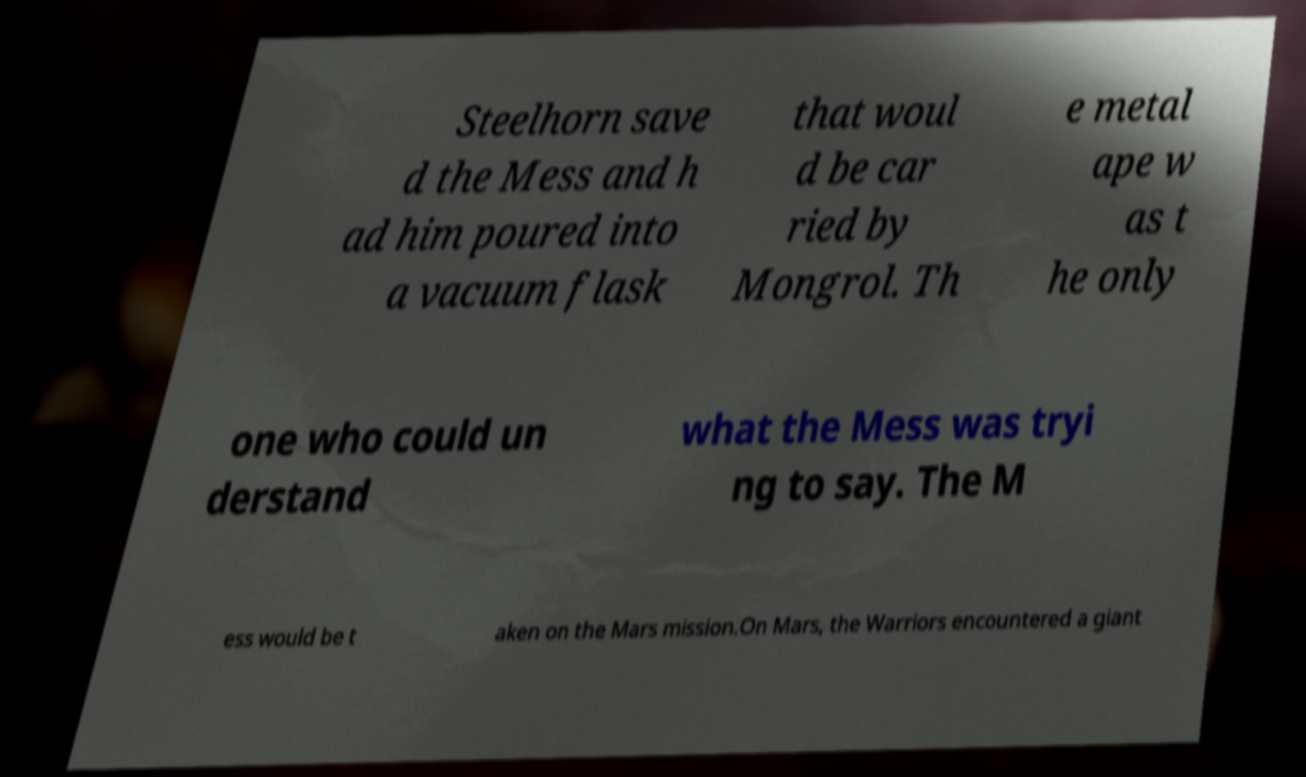Can you read and provide the text displayed in the image?This photo seems to have some interesting text. Can you extract and type it out for me? Steelhorn save d the Mess and h ad him poured into a vacuum flask that woul d be car ried by Mongrol. Th e metal ape w as t he only one who could un derstand what the Mess was tryi ng to say. The M ess would be t aken on the Mars mission.On Mars, the Warriors encountered a giant 